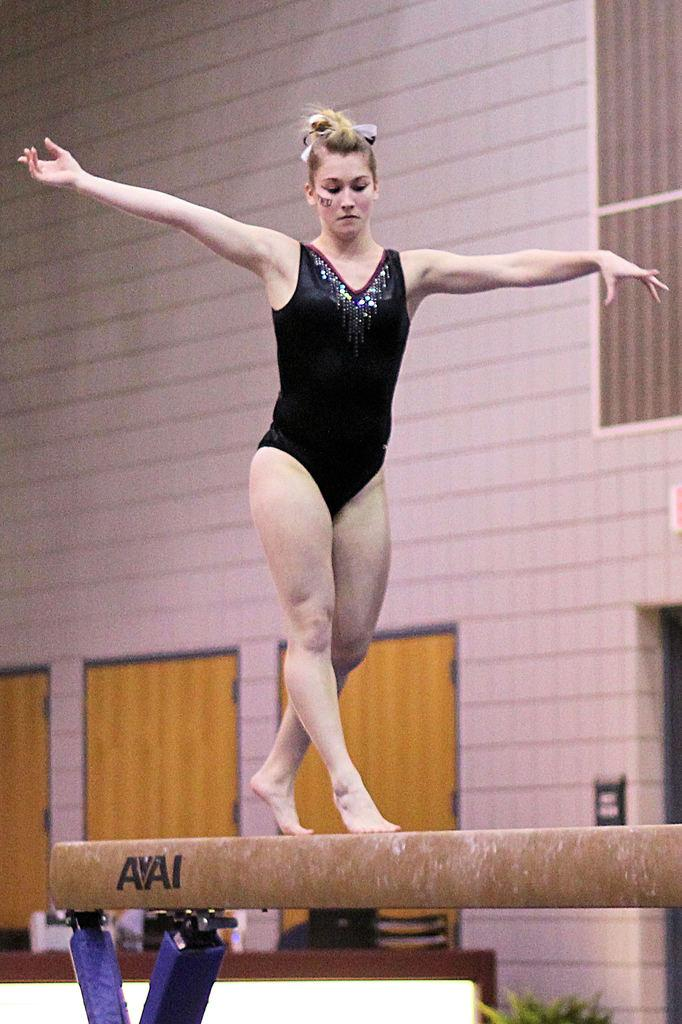What is the woman doing in the image? The woman is standing on a pole in the image. How is the pole supported? The pole is placed on stands in the image. What can be seen in the background of the image? There is a plant, a screen on a table, and a building with doors in the background of the image. What type of transport can be seen in the image? There is no transport visible in the image. What is the value of the plant in the image? The value of the plant cannot be determined from the image alone. 